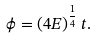<formula> <loc_0><loc_0><loc_500><loc_500>\phi = ( 4 E ) ^ { \frac { 1 } { 4 } } \, t .</formula> 